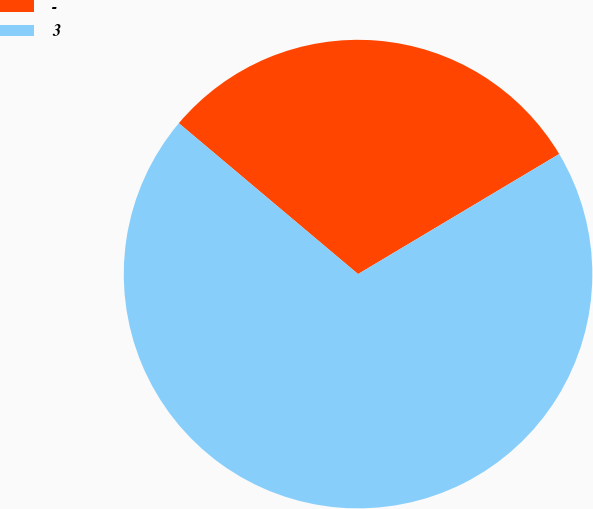Convert chart. <chart><loc_0><loc_0><loc_500><loc_500><pie_chart><fcel>-<fcel>3<nl><fcel>30.3%<fcel>69.7%<nl></chart> 